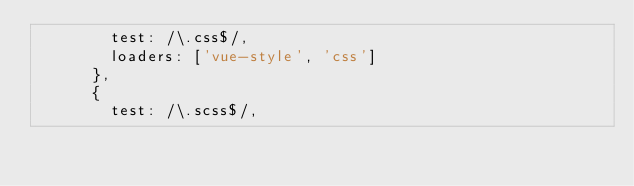<code> <loc_0><loc_0><loc_500><loc_500><_JavaScript_>        test: /\.css$/,
        loaders: ['vue-style', 'css']
      },
      {
        test: /\.scss$/,</code> 